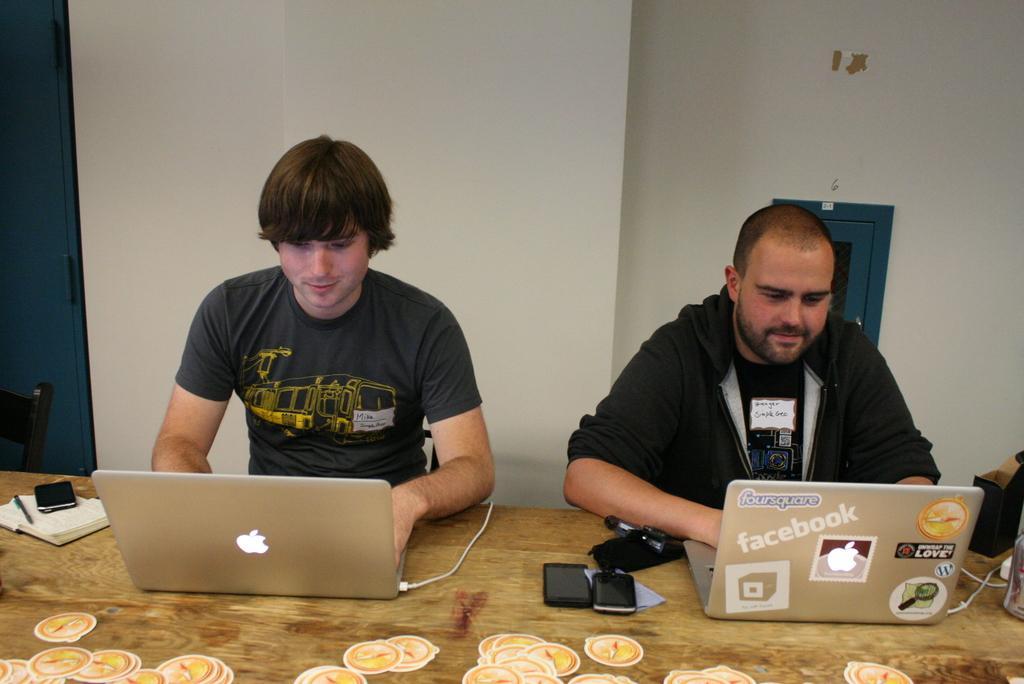How would you summarize this image in a sentence or two? In this picture to the left side there is a man with black t-shirt is sitting in front of the laptop which is on the table. To the left corner of the table there is a book. On top of the book there is a pen and mobile. And to the right side of the picture there is a man with black jacket sitting in front of the table. on the laptop there are some logos on it. Beside that laptop there are two mobiles are there. And to the right corner there is an item. Behind the man there is a small window. 